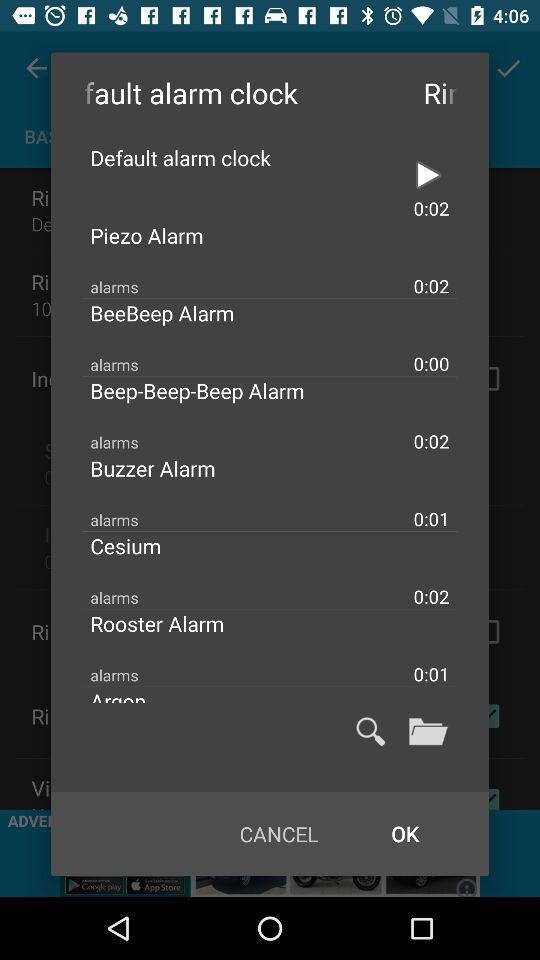What is the setting of the default alarm clock?
When the provided information is insufficient, respond with <no answer>. <no answer> 